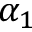Convert formula to latex. <formula><loc_0><loc_0><loc_500><loc_500>\alpha _ { 1 }</formula> 